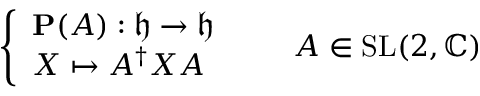<formula> <loc_0><loc_0><loc_500><loc_500>{ \left \{ \begin{array} { l l } { P ( A ) \colon { \mathfrak { h } } \to { \mathfrak { h } } } \\ { X \mapsto A ^ { \dagger } X A } \end{array} } \quad A \in S L ( 2 , \mathbb { C } )</formula> 